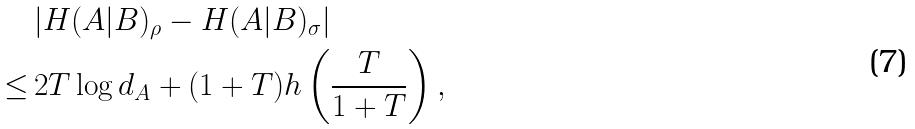<formula> <loc_0><loc_0><loc_500><loc_500>& | H ( A | B ) _ { \rho } - H ( A | B ) _ { \sigma } | \\ \leq \, & 2 T \log d _ { A } + ( 1 + T ) h \left ( \frac { T } { 1 + T } \right ) ,</formula> 